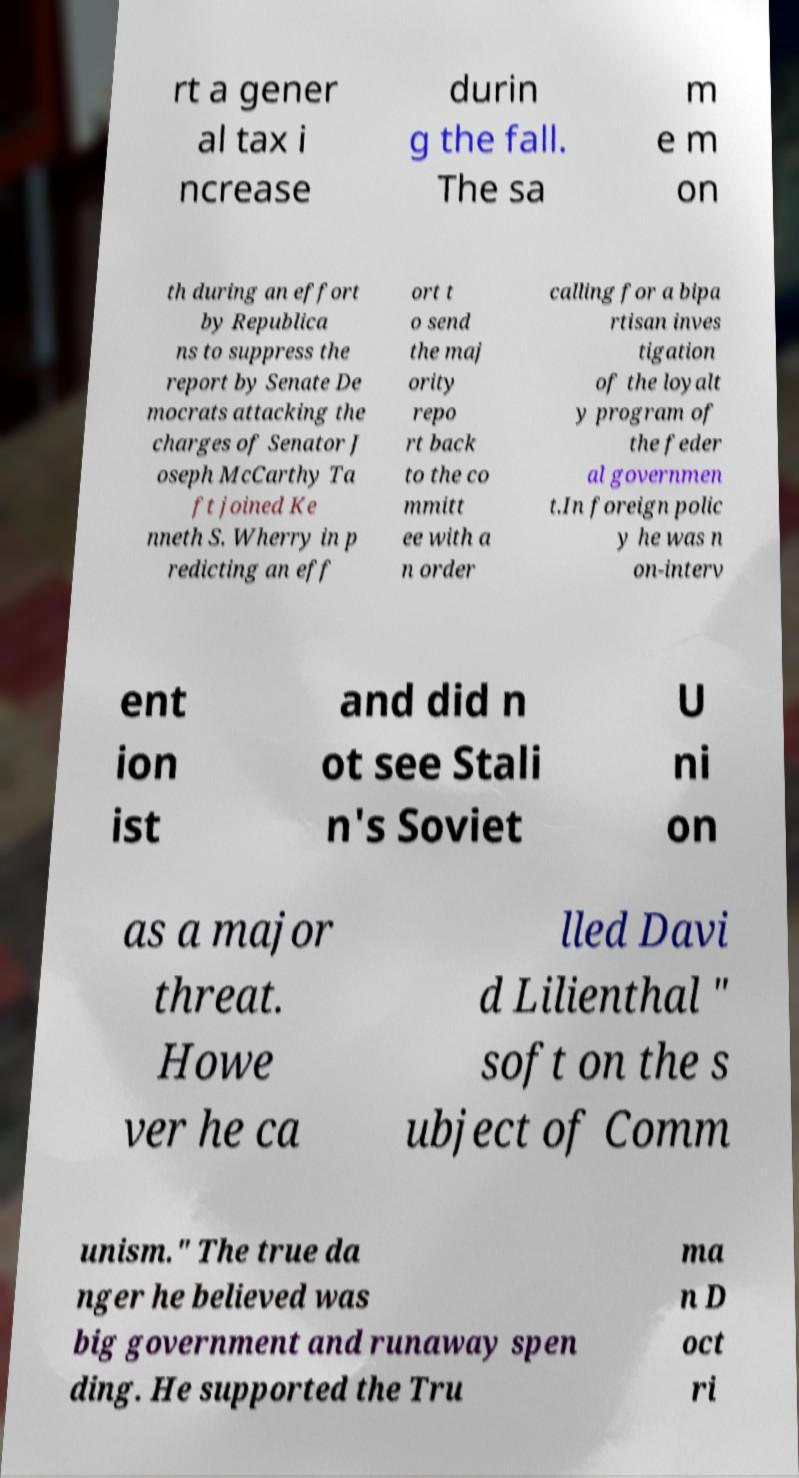What messages or text are displayed in this image? I need them in a readable, typed format. rt a gener al tax i ncrease durin g the fall. The sa m e m on th during an effort by Republica ns to suppress the report by Senate De mocrats attacking the charges of Senator J oseph McCarthy Ta ft joined Ke nneth S. Wherry in p redicting an eff ort t o send the maj ority repo rt back to the co mmitt ee with a n order calling for a bipa rtisan inves tigation of the loyalt y program of the feder al governmen t.In foreign polic y he was n on-interv ent ion ist and did n ot see Stali n's Soviet U ni on as a major threat. Howe ver he ca lled Davi d Lilienthal " soft on the s ubject of Comm unism." The true da nger he believed was big government and runaway spen ding. He supported the Tru ma n D oct ri 